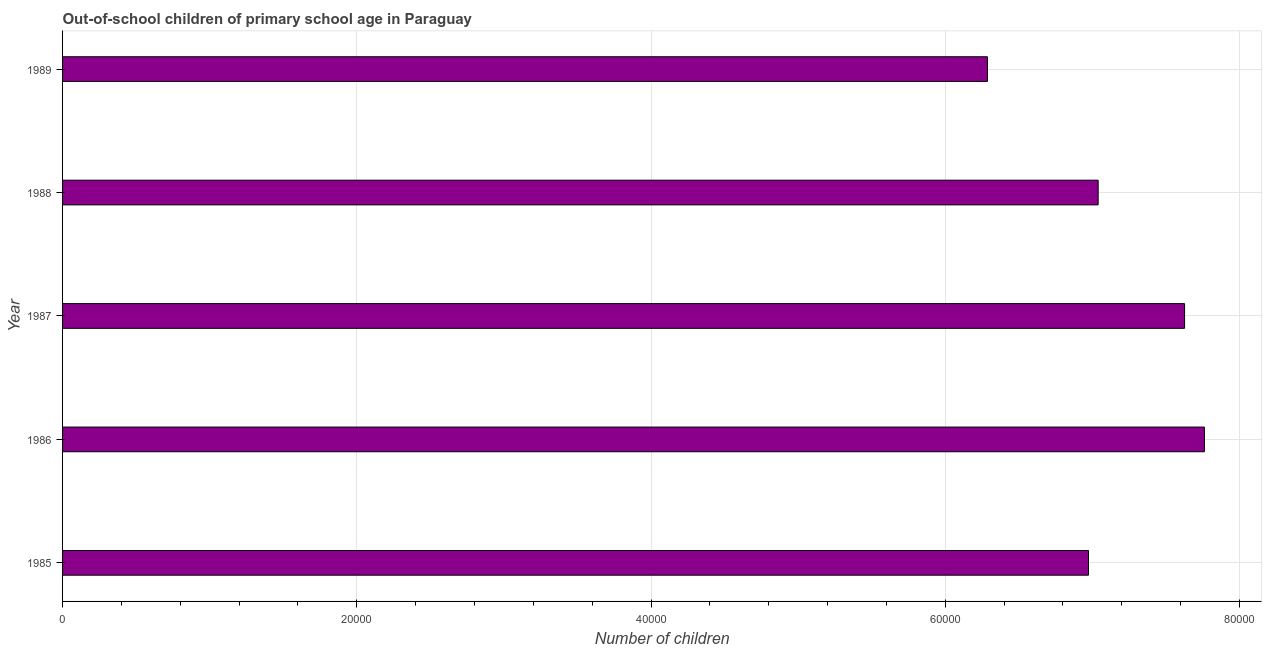What is the title of the graph?
Offer a very short reply. Out-of-school children of primary school age in Paraguay. What is the label or title of the X-axis?
Your response must be concise. Number of children. What is the label or title of the Y-axis?
Ensure brevity in your answer.  Year. What is the number of out-of-school children in 1986?
Offer a terse response. 7.76e+04. Across all years, what is the maximum number of out-of-school children?
Your answer should be compact. 7.76e+04. Across all years, what is the minimum number of out-of-school children?
Keep it short and to the point. 6.29e+04. In which year was the number of out-of-school children maximum?
Provide a short and direct response. 1986. What is the sum of the number of out-of-school children?
Offer a very short reply. 3.57e+05. What is the difference between the number of out-of-school children in 1985 and 1989?
Offer a terse response. 6868. What is the average number of out-of-school children per year?
Give a very brief answer. 7.14e+04. What is the median number of out-of-school children?
Your answer should be very brief. 7.04e+04. In how many years, is the number of out-of-school children greater than 12000 ?
Keep it short and to the point. 5. What is the ratio of the number of out-of-school children in 1985 to that in 1987?
Your answer should be very brief. 0.91. Is the number of out-of-school children in 1985 less than that in 1987?
Offer a terse response. Yes. What is the difference between the highest and the second highest number of out-of-school children?
Ensure brevity in your answer.  1347. What is the difference between the highest and the lowest number of out-of-school children?
Provide a short and direct response. 1.47e+04. How many bars are there?
Provide a succinct answer. 5. How many years are there in the graph?
Make the answer very short. 5. What is the Number of children in 1985?
Ensure brevity in your answer.  6.97e+04. What is the Number of children of 1986?
Provide a succinct answer. 7.76e+04. What is the Number of children in 1987?
Make the answer very short. 7.63e+04. What is the Number of children in 1988?
Your response must be concise. 7.04e+04. What is the Number of children in 1989?
Provide a short and direct response. 6.29e+04. What is the difference between the Number of children in 1985 and 1986?
Offer a terse response. -7878. What is the difference between the Number of children in 1985 and 1987?
Provide a succinct answer. -6531. What is the difference between the Number of children in 1985 and 1988?
Your answer should be very brief. -656. What is the difference between the Number of children in 1985 and 1989?
Provide a short and direct response. 6868. What is the difference between the Number of children in 1986 and 1987?
Keep it short and to the point. 1347. What is the difference between the Number of children in 1986 and 1988?
Provide a short and direct response. 7222. What is the difference between the Number of children in 1986 and 1989?
Keep it short and to the point. 1.47e+04. What is the difference between the Number of children in 1987 and 1988?
Provide a short and direct response. 5875. What is the difference between the Number of children in 1987 and 1989?
Give a very brief answer. 1.34e+04. What is the difference between the Number of children in 1988 and 1989?
Give a very brief answer. 7524. What is the ratio of the Number of children in 1985 to that in 1986?
Give a very brief answer. 0.9. What is the ratio of the Number of children in 1985 to that in 1987?
Make the answer very short. 0.91. What is the ratio of the Number of children in 1985 to that in 1988?
Give a very brief answer. 0.99. What is the ratio of the Number of children in 1985 to that in 1989?
Keep it short and to the point. 1.11. What is the ratio of the Number of children in 1986 to that in 1988?
Offer a very short reply. 1.1. What is the ratio of the Number of children in 1986 to that in 1989?
Make the answer very short. 1.24. What is the ratio of the Number of children in 1987 to that in 1988?
Offer a very short reply. 1.08. What is the ratio of the Number of children in 1987 to that in 1989?
Your answer should be compact. 1.21. What is the ratio of the Number of children in 1988 to that in 1989?
Keep it short and to the point. 1.12. 